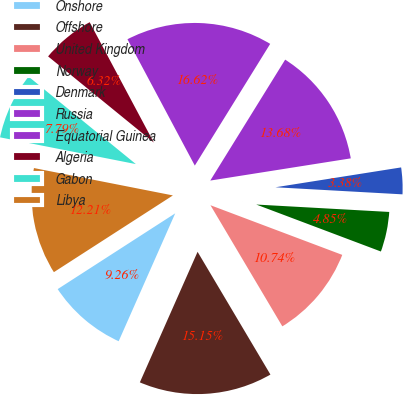Convert chart. <chart><loc_0><loc_0><loc_500><loc_500><pie_chart><fcel>Onshore<fcel>Offshore<fcel>United Kingdom<fcel>Norway<fcel>Denmark<fcel>Russia<fcel>Equatorial Guinea<fcel>Algeria<fcel>Gabon<fcel>Libya<nl><fcel>9.26%<fcel>15.15%<fcel>10.74%<fcel>4.85%<fcel>3.38%<fcel>13.68%<fcel>16.62%<fcel>6.32%<fcel>7.79%<fcel>12.21%<nl></chart> 